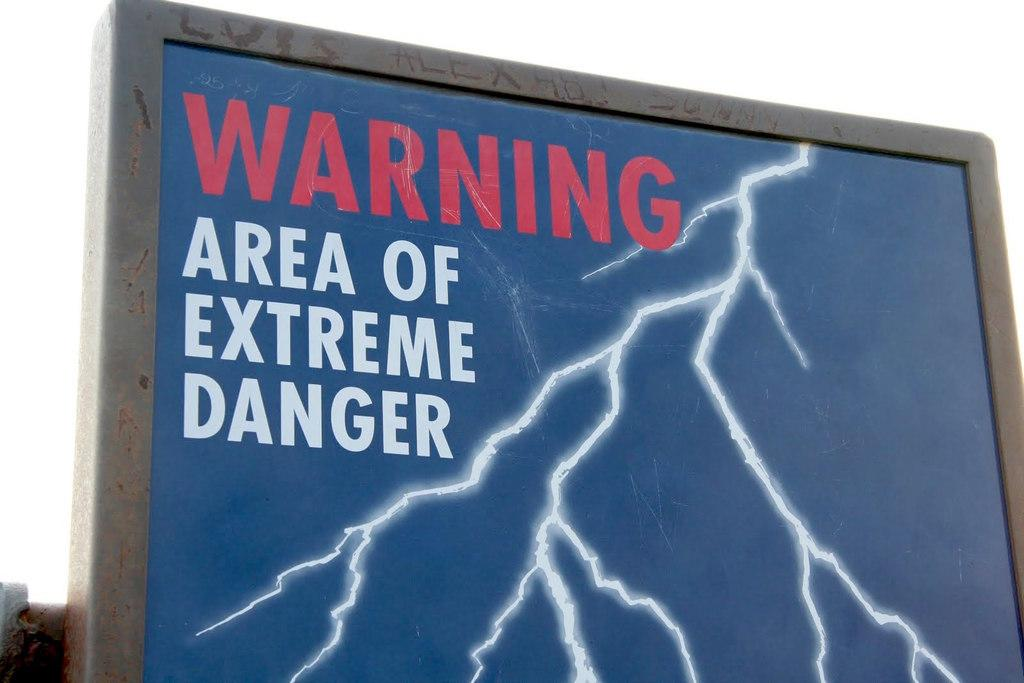Provide a one-sentence caption for the provided image. A sign with a lightening bolt is a warning that this is an area of extreme danger. 